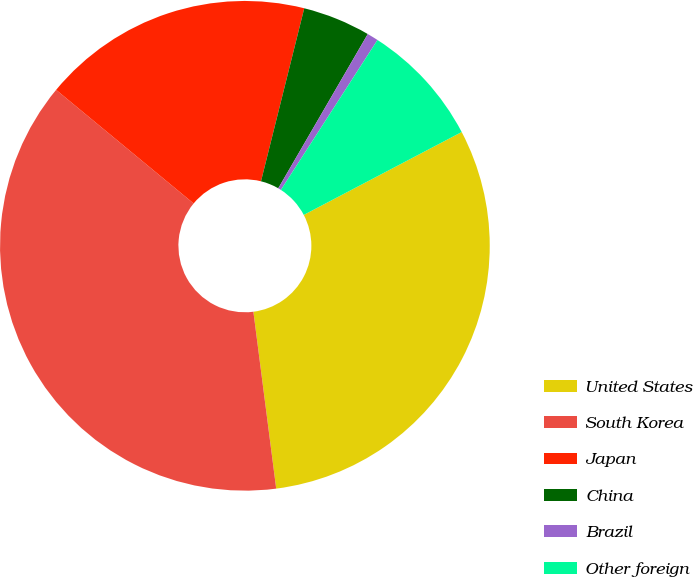<chart> <loc_0><loc_0><loc_500><loc_500><pie_chart><fcel>United States<fcel>South Korea<fcel>Japan<fcel>China<fcel>Brazil<fcel>Other foreign<nl><fcel>30.65%<fcel>38.03%<fcel>17.91%<fcel>4.47%<fcel>0.74%<fcel>8.2%<nl></chart> 